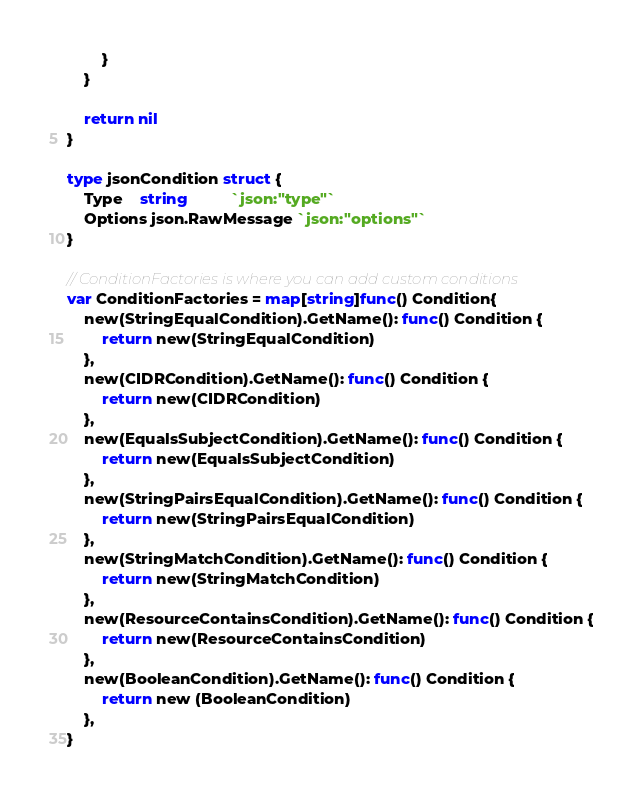Convert code to text. <code><loc_0><loc_0><loc_500><loc_500><_Go_>		}
	}

	return nil
}

type jsonCondition struct {
	Type    string          `json:"type"`
	Options json.RawMessage `json:"options"`
}

// ConditionFactories is where you can add custom conditions
var ConditionFactories = map[string]func() Condition{
	new(StringEqualCondition).GetName(): func() Condition {
		return new(StringEqualCondition)
	},
	new(CIDRCondition).GetName(): func() Condition {
		return new(CIDRCondition)
	},
	new(EqualsSubjectCondition).GetName(): func() Condition {
		return new(EqualsSubjectCondition)
	},
	new(StringPairsEqualCondition).GetName(): func() Condition {
		return new(StringPairsEqualCondition)
	},
	new(StringMatchCondition).GetName(): func() Condition {
		return new(StringMatchCondition)
	},
	new(ResourceContainsCondition).GetName(): func() Condition {
		return new(ResourceContainsCondition)
	},
	new(BooleanCondition).GetName(): func() Condition {
		return new (BooleanCondition)
	},
}
</code> 